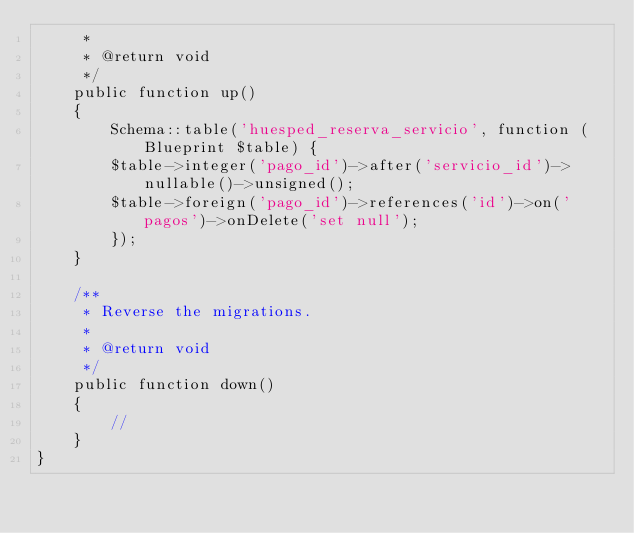<code> <loc_0><loc_0><loc_500><loc_500><_PHP_>     *
     * @return void
     */
    public function up()
    {
        Schema::table('huesped_reserva_servicio', function (Blueprint $table) {
        $table->integer('pago_id')->after('servicio_id')->nullable()->unsigned();
        $table->foreign('pago_id')->references('id')->on('pagos')->onDelete('set null');
        });
    }

    /**
     * Reverse the migrations.
     *
     * @return void
     */
    public function down()
    {
        //
    }
}
</code> 